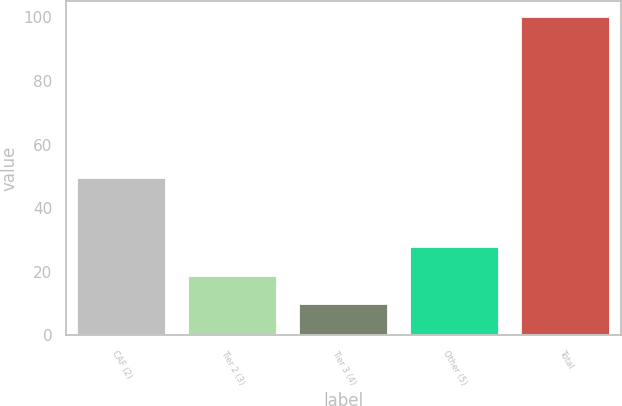<chart> <loc_0><loc_0><loc_500><loc_500><bar_chart><fcel>CAF (2)<fcel>Tier 2 (3)<fcel>Tier 3 (4)<fcel>Other (5)<fcel>Total<nl><fcel>49.5<fcel>18.82<fcel>9.8<fcel>27.84<fcel>100<nl></chart> 